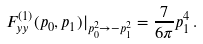<formula> <loc_0><loc_0><loc_500><loc_500>F ^ { ( 1 ) } _ { y y } ( p _ { 0 } , p _ { 1 } ) { | _ { p _ { 0 } ^ { 2 } \rightarrow - p _ { 1 } ^ { 2 } } } = \frac { 7 } { 6 \pi } p _ { 1 } ^ { 4 } \, .</formula> 